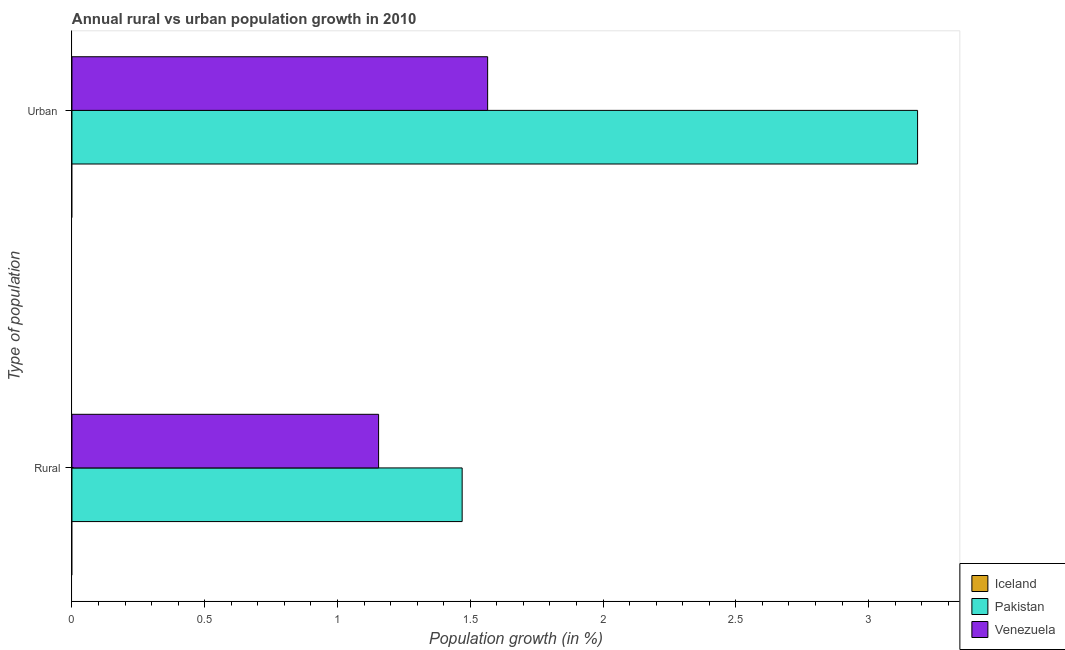How many bars are there on the 1st tick from the bottom?
Keep it short and to the point. 2. What is the label of the 1st group of bars from the top?
Make the answer very short. Urban . Across all countries, what is the maximum urban population growth?
Offer a terse response. 3.18. Across all countries, what is the minimum urban population growth?
Provide a short and direct response. 0. What is the total rural population growth in the graph?
Make the answer very short. 2.62. What is the difference between the urban population growth in Venezuela and that in Pakistan?
Your response must be concise. -1.62. What is the difference between the urban population growth in Iceland and the rural population growth in Pakistan?
Provide a succinct answer. -1.47. What is the average urban population growth per country?
Provide a short and direct response. 1.58. What is the difference between the urban population growth and rural population growth in Pakistan?
Offer a very short reply. 1.71. In how many countries, is the urban population growth greater than 1.2 %?
Offer a terse response. 2. What is the ratio of the rural population growth in Venezuela to that in Pakistan?
Your answer should be compact. 0.79. Are all the bars in the graph horizontal?
Make the answer very short. Yes. How many countries are there in the graph?
Give a very brief answer. 3. What is the difference between two consecutive major ticks on the X-axis?
Ensure brevity in your answer.  0.5. Are the values on the major ticks of X-axis written in scientific E-notation?
Offer a very short reply. No. Does the graph contain any zero values?
Offer a terse response. Yes. Does the graph contain grids?
Offer a very short reply. No. Where does the legend appear in the graph?
Offer a terse response. Bottom right. How many legend labels are there?
Your answer should be very brief. 3. What is the title of the graph?
Give a very brief answer. Annual rural vs urban population growth in 2010. Does "Arab World" appear as one of the legend labels in the graph?
Your answer should be very brief. No. What is the label or title of the X-axis?
Ensure brevity in your answer.  Population growth (in %). What is the label or title of the Y-axis?
Offer a terse response. Type of population. What is the Population growth (in %) in Pakistan in Rural?
Your answer should be compact. 1.47. What is the Population growth (in %) in Venezuela in Rural?
Your response must be concise. 1.15. What is the Population growth (in %) in Iceland in Urban ?
Offer a terse response. 0. What is the Population growth (in %) of Pakistan in Urban ?
Provide a succinct answer. 3.18. What is the Population growth (in %) in Venezuela in Urban ?
Provide a short and direct response. 1.57. Across all Type of population, what is the maximum Population growth (in %) of Pakistan?
Your answer should be compact. 3.18. Across all Type of population, what is the maximum Population growth (in %) in Venezuela?
Provide a succinct answer. 1.57. Across all Type of population, what is the minimum Population growth (in %) in Pakistan?
Offer a very short reply. 1.47. Across all Type of population, what is the minimum Population growth (in %) in Venezuela?
Offer a very short reply. 1.15. What is the total Population growth (in %) in Pakistan in the graph?
Offer a terse response. 4.65. What is the total Population growth (in %) of Venezuela in the graph?
Provide a short and direct response. 2.72. What is the difference between the Population growth (in %) of Pakistan in Rural and that in Urban ?
Offer a terse response. -1.71. What is the difference between the Population growth (in %) of Venezuela in Rural and that in Urban ?
Offer a very short reply. -0.41. What is the difference between the Population growth (in %) of Pakistan in Rural and the Population growth (in %) of Venezuela in Urban ?
Provide a short and direct response. -0.1. What is the average Population growth (in %) in Pakistan per Type of population?
Provide a short and direct response. 2.33. What is the average Population growth (in %) in Venezuela per Type of population?
Offer a very short reply. 1.36. What is the difference between the Population growth (in %) in Pakistan and Population growth (in %) in Venezuela in Rural?
Your answer should be very brief. 0.31. What is the difference between the Population growth (in %) of Pakistan and Population growth (in %) of Venezuela in Urban ?
Keep it short and to the point. 1.62. What is the ratio of the Population growth (in %) in Pakistan in Rural to that in Urban ?
Ensure brevity in your answer.  0.46. What is the ratio of the Population growth (in %) in Venezuela in Rural to that in Urban ?
Ensure brevity in your answer.  0.74. What is the difference between the highest and the second highest Population growth (in %) in Pakistan?
Your response must be concise. 1.71. What is the difference between the highest and the second highest Population growth (in %) in Venezuela?
Offer a terse response. 0.41. What is the difference between the highest and the lowest Population growth (in %) in Pakistan?
Offer a very short reply. 1.71. What is the difference between the highest and the lowest Population growth (in %) of Venezuela?
Make the answer very short. 0.41. 